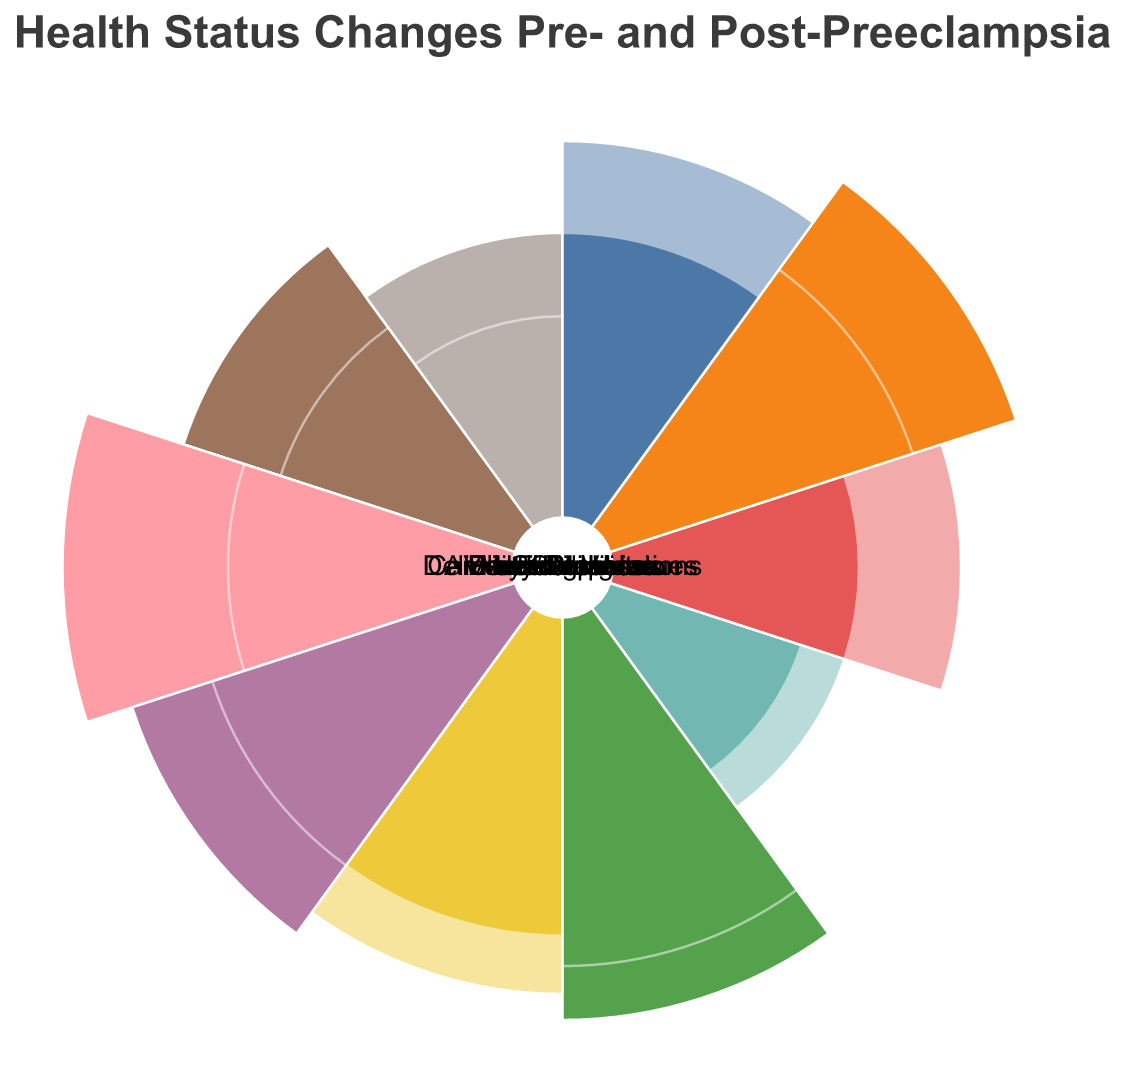What is the title of the figure? The title is located at the top of the chart and summarizes the content of the chart.
Answer: Health Status Changes Pre- and Post-Preeclampsia Which category had the highest score pre-preeclampsia? By looking at the length of the arc segments, the category with the longest arc segment in the pre-preeclampsia layer has the highest score.
Answer: Protein in Urine How did the score for headaches change from pre- to post-preeclampsia? The chart contains two arcs for each category: one for pre-preeclampsia and one for post-preeclampsia. The comparison of length and opacity for the "Headaches" category shows the change in score.
Answer: Increased from 5 to 7 Which category shows a decrease in score post-preeclampsia? By comparing the lengths of the arc segments for each category, several categories show a decrease. Specific categories with notable decreases include Swelling, Blood Pressure, Protein in Urine, Fatigue, Vision Problems, and Medical Visits.
Answer: Swelling, Blood Pressure, Protein in Urine, Fatigue, Vision Problems, Medical Visits Which category depicted an increase in score post-preeclampsia related to mental health symptoms? By looking at the categories related to mental health and comparing the arc segments, the category related to mental health is "Anxiety/Depression," which shows an increase.
Answer: Anxiety/Depression What was the score change for cardiovascular issues from pre- to post-preeclampsia? Compare the length of the arc segments for "Cardiovascular Issues" before and after preeclampsia.
Answer: Increased from 3 to 6 What is the average pre-preeclampsia score across all categories? Add all the pre-preeclampsia scores and divide by the number of categories (10 categories). (5+6+9+10+8+4+8+2+3+4)/10 = 59/10
Answer: 5.9 Which category shows the smallest difference in score between pre- and post-preeclampsia? Calculate the absolute difference between pre- and post-preeclampsia scores for each category: Headaches (2), Swelling (3), Blood Pressure (4), Protein in Urine (6), Fatigue (2), Vision Problems (2), Medical Visits (3), Delivery Complications (1), Cardiovascular Issues (3), Anxiety/Depression (3). The smallest difference is for "Delivery Complications".
Answer: Delivery Complications How did the total number of medical visits change from pre- to post-preeclampsia? Looking at the category "Medical Visits" and comparing the arc segments for pre- and post-preeclampsia, measure the difference.
Answer: Decreased from 8 to 5 